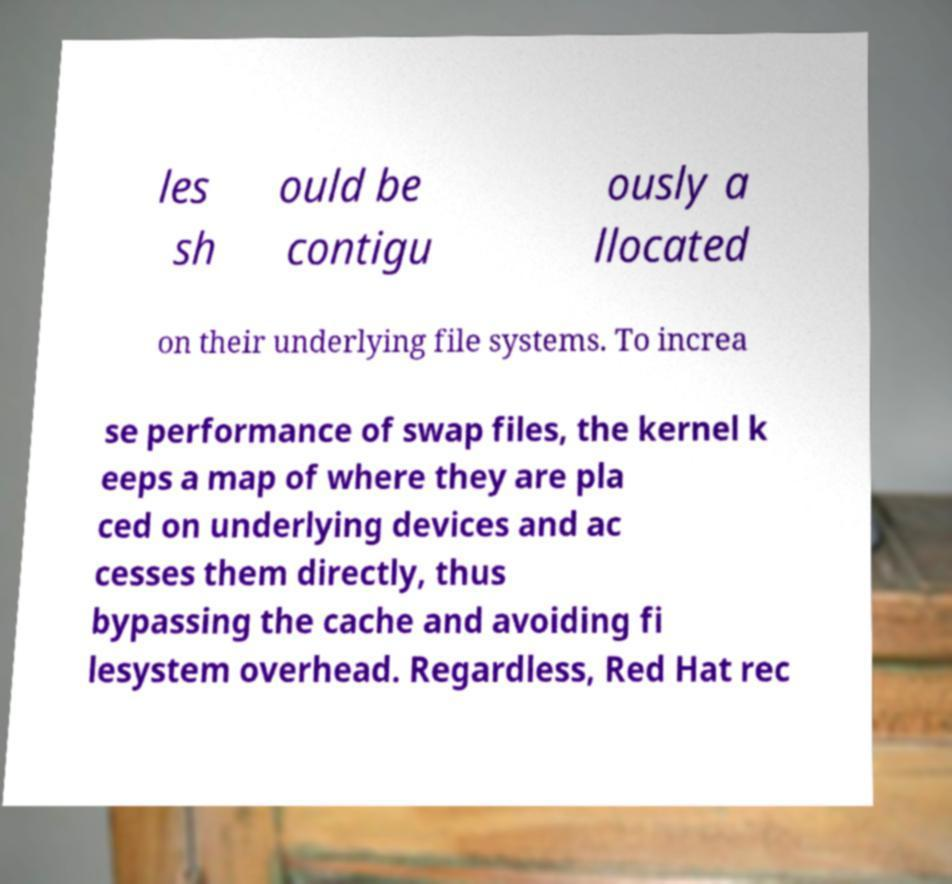Please identify and transcribe the text found in this image. les sh ould be contigu ously a llocated on their underlying file systems. To increa se performance of swap files, the kernel k eeps a map of where they are pla ced on underlying devices and ac cesses them directly, thus bypassing the cache and avoiding fi lesystem overhead. Regardless, Red Hat rec 